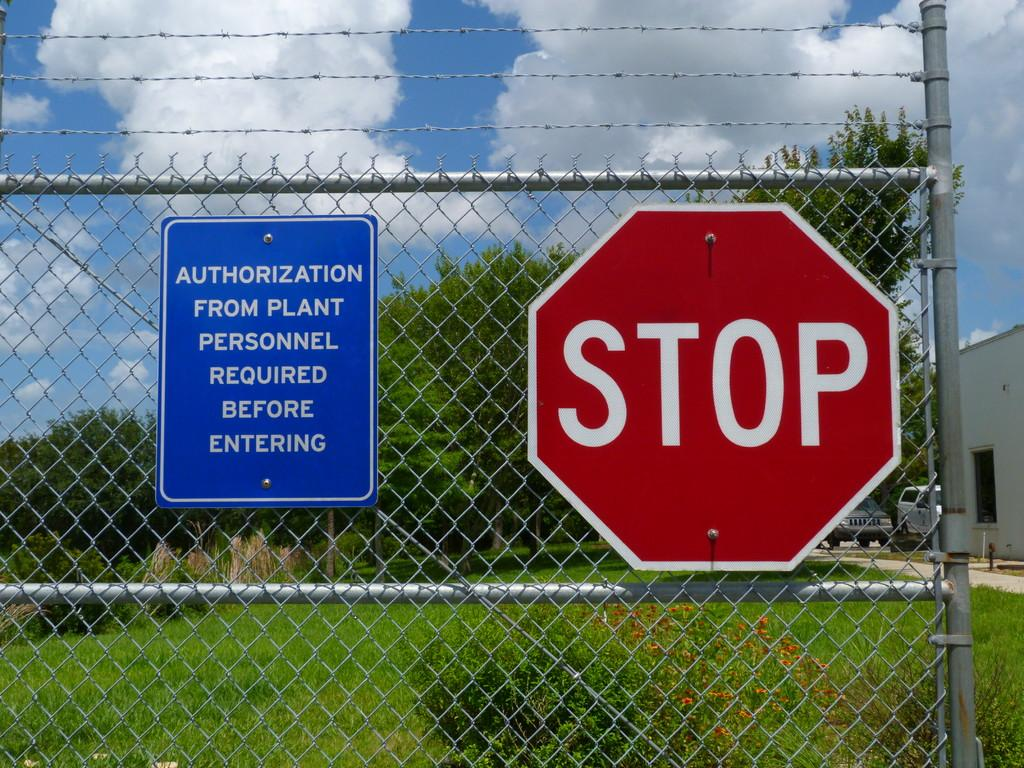<image>
Provide a brief description of the given image. A stop sign next to a sign that says Authorization from plant personnel required on a fence. 